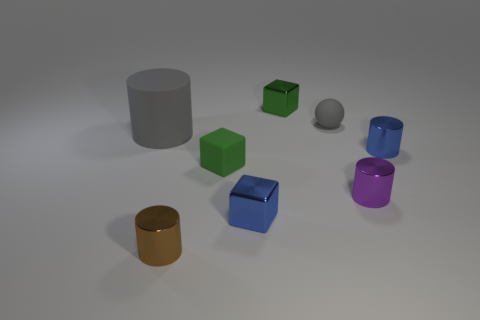What is the size of the cylinder that is the same color as the tiny ball?
Provide a succinct answer. Large. There is a tiny matte sphere; how many gray objects are left of it?
Ensure brevity in your answer.  1. What is the brown thing made of?
Keep it short and to the point. Metal. Does the rubber cylinder have the same color as the small sphere?
Your answer should be compact. Yes. Are there fewer green metallic cubes in front of the tiny green matte block than brown shiny spheres?
Your answer should be compact. No. There is a tiny metal cube in front of the green matte block; what is its color?
Keep it short and to the point. Blue. What shape is the green metallic object?
Give a very brief answer. Cube. There is a small blue object on the right side of the small rubber thing that is right of the green metal thing; is there a rubber sphere in front of it?
Make the answer very short. No. What is the color of the metallic cylinder that is on the left side of the blue metal thing that is to the left of the gray thing behind the big gray object?
Make the answer very short. Brown. There is another big thing that is the same shape as the brown shiny thing; what material is it?
Offer a terse response. Rubber. 